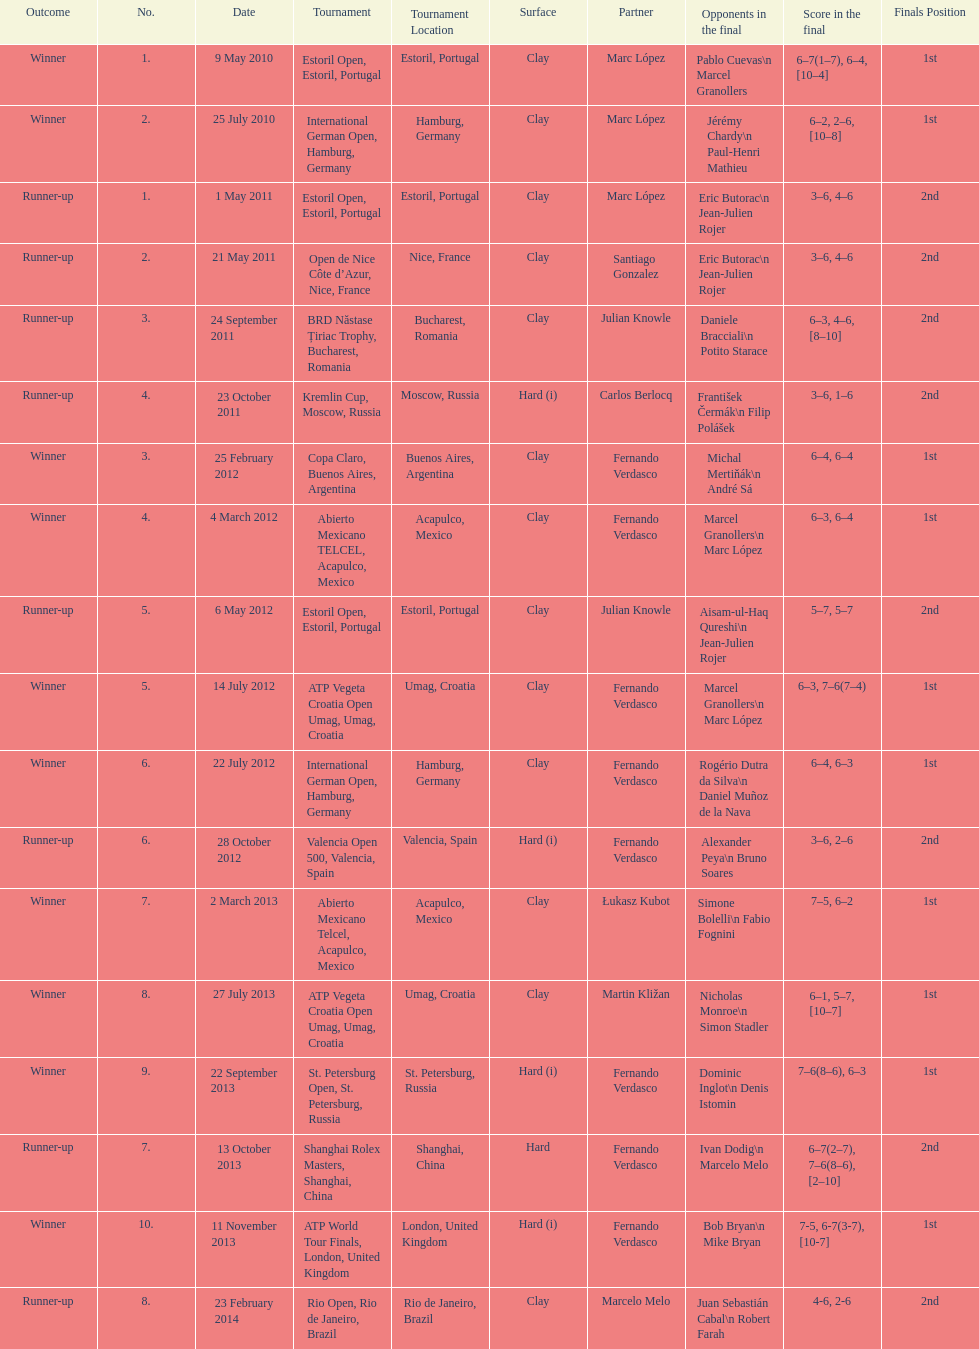How many tournaments has this player won in his career so far? 10. I'm looking to parse the entire table for insights. Could you assist me with that? {'header': ['Outcome', 'No.', 'Date', 'Tournament', 'Tournament Location', 'Surface', 'Partner', 'Opponents in the final', 'Score in the final', 'Finals Position'], 'rows': [['Winner', '1.', '9 May 2010', 'Estoril Open, Estoril, Portugal', 'Estoril, Portugal', 'Clay', 'Marc López', 'Pablo Cuevas\\n Marcel Granollers', '6–7(1–7), 6–4, [10–4]', '1st'], ['Winner', '2.', '25 July 2010', 'International German Open, Hamburg, Germany', 'Hamburg, Germany', 'Clay', 'Marc López', 'Jérémy Chardy\\n Paul-Henri Mathieu', '6–2, 2–6, [10–8]', '1st'], ['Runner-up', '1.', '1 May 2011', 'Estoril Open, Estoril, Portugal', 'Estoril, Portugal', 'Clay', 'Marc López', 'Eric Butorac\\n Jean-Julien Rojer', '3–6, 4–6', '2nd'], ['Runner-up', '2.', '21 May 2011', 'Open de Nice Côte d’Azur, Nice, France', 'Nice, France', 'Clay', 'Santiago Gonzalez', 'Eric Butorac\\n Jean-Julien Rojer', '3–6, 4–6', '2nd'], ['Runner-up', '3.', '24 September 2011', 'BRD Năstase Țiriac Trophy, Bucharest, Romania', 'Bucharest, Romania', 'Clay', 'Julian Knowle', 'Daniele Bracciali\\n Potito Starace', '6–3, 4–6, [8–10]', '2nd'], ['Runner-up', '4.', '23 October 2011', 'Kremlin Cup, Moscow, Russia', 'Moscow, Russia', 'Hard (i)', 'Carlos Berlocq', 'František Čermák\\n Filip Polášek', '3–6, 1–6', '2nd'], ['Winner', '3.', '25 February 2012', 'Copa Claro, Buenos Aires, Argentina', 'Buenos Aires, Argentina', 'Clay', 'Fernando Verdasco', 'Michal Mertiňák\\n André Sá', '6–4, 6–4', '1st'], ['Winner', '4.', '4 March 2012', 'Abierto Mexicano TELCEL, Acapulco, Mexico', 'Acapulco, Mexico', 'Clay', 'Fernando Verdasco', 'Marcel Granollers\\n Marc López', '6–3, 6–4', '1st'], ['Runner-up', '5.', '6 May 2012', 'Estoril Open, Estoril, Portugal', 'Estoril, Portugal', 'Clay', 'Julian Knowle', 'Aisam-ul-Haq Qureshi\\n Jean-Julien Rojer', '5–7, 5–7', '2nd'], ['Winner', '5.', '14 July 2012', 'ATP Vegeta Croatia Open Umag, Umag, Croatia', 'Umag, Croatia', 'Clay', 'Fernando Verdasco', 'Marcel Granollers\\n Marc López', '6–3, 7–6(7–4)', '1st'], ['Winner', '6.', '22 July 2012', 'International German Open, Hamburg, Germany', 'Hamburg, Germany', 'Clay', 'Fernando Verdasco', 'Rogério Dutra da Silva\\n Daniel Muñoz de la Nava', '6–4, 6–3', '1st'], ['Runner-up', '6.', '28 October 2012', 'Valencia Open 500, Valencia, Spain', 'Valencia, Spain', 'Hard (i)', 'Fernando Verdasco', 'Alexander Peya\\n Bruno Soares', '3–6, 2–6', '2nd'], ['Winner', '7.', '2 March 2013', 'Abierto Mexicano Telcel, Acapulco, Mexico', 'Acapulco, Mexico', 'Clay', 'Łukasz Kubot', 'Simone Bolelli\\n Fabio Fognini', '7–5, 6–2', '1st'], ['Winner', '8.', '27 July 2013', 'ATP Vegeta Croatia Open Umag, Umag, Croatia', 'Umag, Croatia', 'Clay', 'Martin Kližan', 'Nicholas Monroe\\n Simon Stadler', '6–1, 5–7, [10–7]', '1st'], ['Winner', '9.', '22 September 2013', 'St. Petersburg Open, St. Petersburg, Russia', 'St. Petersburg, Russia', 'Hard (i)', 'Fernando Verdasco', 'Dominic Inglot\\n Denis Istomin', '7–6(8–6), 6–3', '1st'], ['Runner-up', '7.', '13 October 2013', 'Shanghai Rolex Masters, Shanghai, China', 'Shanghai, China', 'Hard', 'Fernando Verdasco', 'Ivan Dodig\\n Marcelo Melo', '6–7(2–7), 7–6(8–6), [2–10]', '2nd'], ['Winner', '10.', '11 November 2013', 'ATP World Tour Finals, London, United Kingdom', 'London, United Kingdom', 'Hard (i)', 'Fernando Verdasco', 'Bob Bryan\\n Mike Bryan', '7-5, 6-7(3-7), [10-7]', '1st'], ['Runner-up', '8.', '23 February 2014', 'Rio Open, Rio de Janeiro, Brazil', 'Rio de Janeiro, Brazil', 'Clay', 'Marcelo Melo', 'Juan Sebastián Cabal\\n Robert Farah', '4-6, 2-6', '2nd']]} 